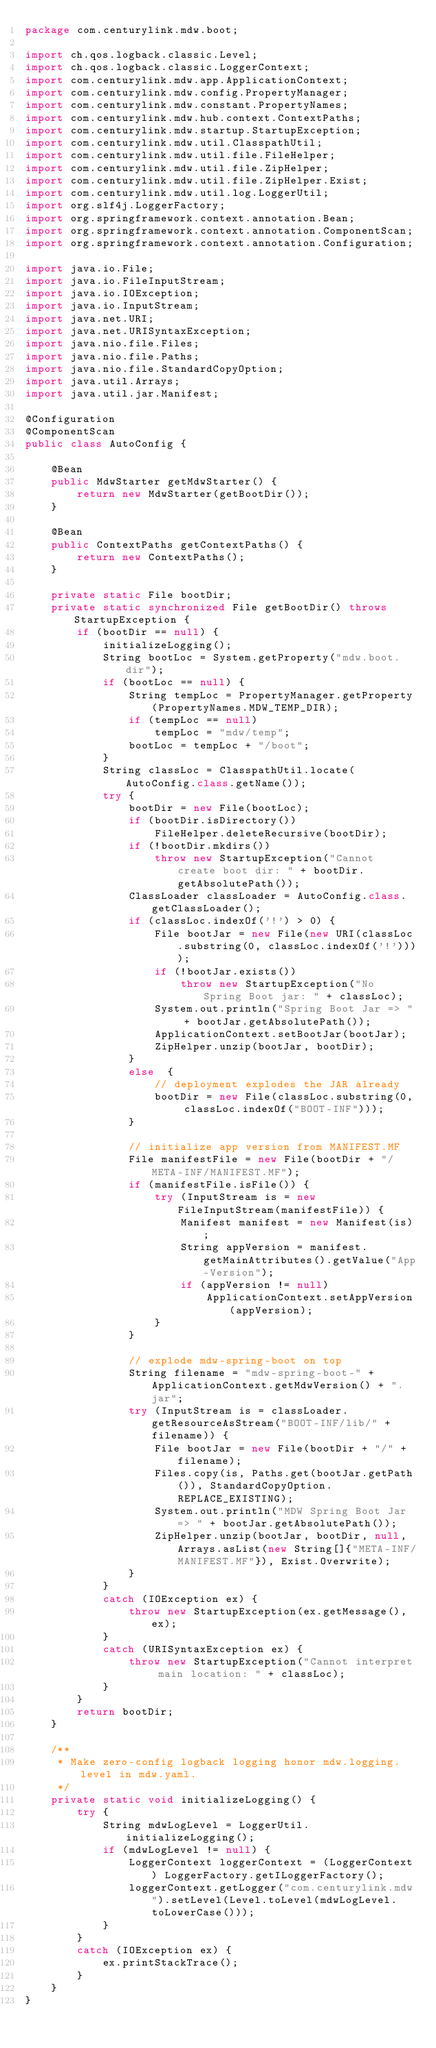Convert code to text. <code><loc_0><loc_0><loc_500><loc_500><_Java_>package com.centurylink.mdw.boot;

import ch.qos.logback.classic.Level;
import ch.qos.logback.classic.LoggerContext;
import com.centurylink.mdw.app.ApplicationContext;
import com.centurylink.mdw.config.PropertyManager;
import com.centurylink.mdw.constant.PropertyNames;
import com.centurylink.mdw.hub.context.ContextPaths;
import com.centurylink.mdw.startup.StartupException;
import com.centurylink.mdw.util.ClasspathUtil;
import com.centurylink.mdw.util.file.FileHelper;
import com.centurylink.mdw.util.file.ZipHelper;
import com.centurylink.mdw.util.file.ZipHelper.Exist;
import com.centurylink.mdw.util.log.LoggerUtil;
import org.slf4j.LoggerFactory;
import org.springframework.context.annotation.Bean;
import org.springframework.context.annotation.ComponentScan;
import org.springframework.context.annotation.Configuration;

import java.io.File;
import java.io.FileInputStream;
import java.io.IOException;
import java.io.InputStream;
import java.net.URI;
import java.net.URISyntaxException;
import java.nio.file.Files;
import java.nio.file.Paths;
import java.nio.file.StandardCopyOption;
import java.util.Arrays;
import java.util.jar.Manifest;

@Configuration
@ComponentScan
public class AutoConfig {

    @Bean
    public MdwStarter getMdwStarter() {
        return new MdwStarter(getBootDir());
    }

    @Bean
    public ContextPaths getContextPaths() {
        return new ContextPaths();
    }

    private static File bootDir;
    private static synchronized File getBootDir() throws StartupException {
        if (bootDir == null) {
            initializeLogging();
            String bootLoc = System.getProperty("mdw.boot.dir");
            if (bootLoc == null) {
                String tempLoc = PropertyManager.getProperty(PropertyNames.MDW_TEMP_DIR);
                if (tempLoc == null)
                    tempLoc = "mdw/temp";
                bootLoc = tempLoc + "/boot";
            }
            String classLoc = ClasspathUtil.locate(AutoConfig.class.getName());
            try {
                bootDir = new File(bootLoc);
                if (bootDir.isDirectory())
                    FileHelper.deleteRecursive(bootDir);
                if (!bootDir.mkdirs())
                    throw new StartupException("Cannot create boot dir: " + bootDir.getAbsolutePath());
                ClassLoader classLoader = AutoConfig.class.getClassLoader();
                if (classLoc.indexOf('!') > 0) {
                    File bootJar = new File(new URI(classLoc.substring(0, classLoc.indexOf('!'))));
                    if (!bootJar.exists())
                        throw new StartupException("No Spring Boot jar: " + classLoc);
                    System.out.println("Spring Boot Jar => " + bootJar.getAbsolutePath());
                    ApplicationContext.setBootJar(bootJar);
                    ZipHelper.unzip(bootJar, bootDir);
                }
                else  {
                    // deployment explodes the JAR already
                    bootDir = new File(classLoc.substring(0, classLoc.indexOf("BOOT-INF")));
                }

                // initialize app version from MANIFEST.MF
                File manifestFile = new File(bootDir + "/META-INF/MANIFEST.MF");
                if (manifestFile.isFile()) {
                    try (InputStream is = new FileInputStream(manifestFile)) {
                        Manifest manifest = new Manifest(is);
                        String appVersion = manifest.getMainAttributes().getValue("App-Version");
                        if (appVersion != null)
                            ApplicationContext.setAppVersion(appVersion);
                    }
                }

                // explode mdw-spring-boot on top
                String filename = "mdw-spring-boot-" + ApplicationContext.getMdwVersion() + ".jar";
                try (InputStream is = classLoader.getResourceAsStream("BOOT-INF/lib/" + filename)) {
                    File bootJar = new File(bootDir + "/" + filename);
                    Files.copy(is, Paths.get(bootJar.getPath()), StandardCopyOption.REPLACE_EXISTING);
                    System.out.println("MDW Spring Boot Jar => " + bootJar.getAbsolutePath());
                    ZipHelper.unzip(bootJar, bootDir, null, Arrays.asList(new String[]{"META-INF/MANIFEST.MF"}), Exist.Overwrite);
                }
            }
            catch (IOException ex) {
                throw new StartupException(ex.getMessage(), ex);
            }
            catch (URISyntaxException ex) {
                throw new StartupException("Cannot interpret main location: " + classLoc);
            }
        }
        return bootDir;
    }

    /**
     * Make zero-config logback logging honor mdw.logging.level in mdw.yaml.
     */
    private static void initializeLogging() {
        try {
            String mdwLogLevel = LoggerUtil.initializeLogging();
            if (mdwLogLevel != null) {
                LoggerContext loggerContext = (LoggerContext) LoggerFactory.getILoggerFactory();
                loggerContext.getLogger("com.centurylink.mdw").setLevel(Level.toLevel(mdwLogLevel.toLowerCase()));
            }
        }
        catch (IOException ex) {
            ex.printStackTrace();
        }
    }
}
</code> 